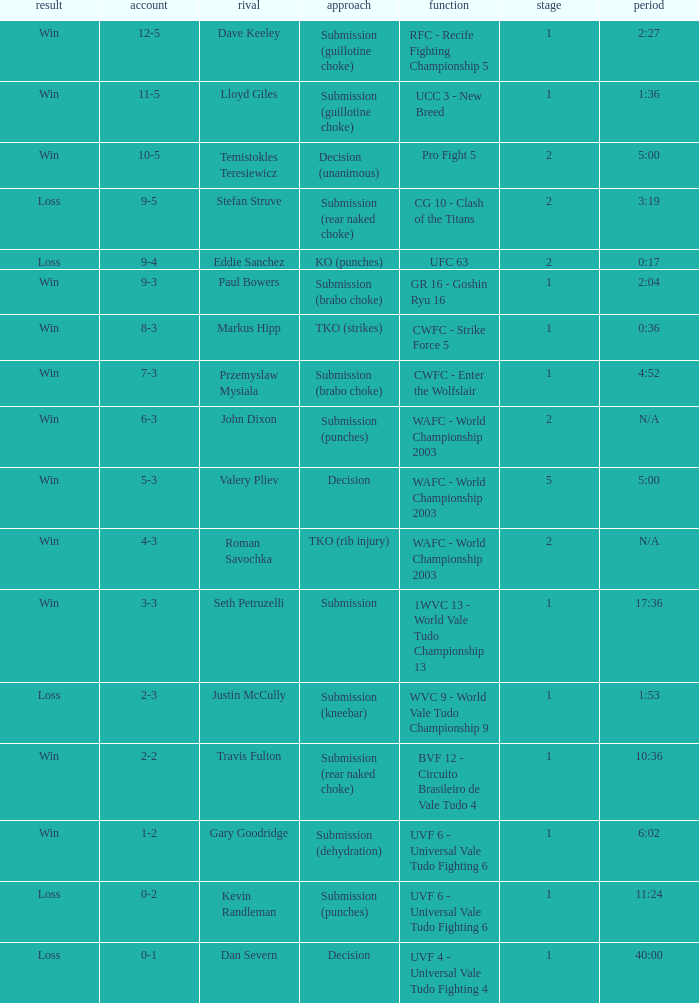What round has the highest Res loss, and a time of 40:00? 1.0. Give me the full table as a dictionary. {'header': ['result', 'account', 'rival', 'approach', 'function', 'stage', 'period'], 'rows': [['Win', '12-5', 'Dave Keeley', 'Submission (guillotine choke)', 'RFC - Recife Fighting Championship 5', '1', '2:27'], ['Win', '11-5', 'Lloyd Giles', 'Submission (guillotine choke)', 'UCC 3 - New Breed', '1', '1:36'], ['Win', '10-5', 'Temistokles Teresiewicz', 'Decision (unanimous)', 'Pro Fight 5', '2', '5:00'], ['Loss', '9-5', 'Stefan Struve', 'Submission (rear naked choke)', 'CG 10 - Clash of the Titans', '2', '3:19'], ['Loss', '9-4', 'Eddie Sanchez', 'KO (punches)', 'UFC 63', '2', '0:17'], ['Win', '9-3', 'Paul Bowers', 'Submission (brabo choke)', 'GR 16 - Goshin Ryu 16', '1', '2:04'], ['Win', '8-3', 'Markus Hipp', 'TKO (strikes)', 'CWFC - Strike Force 5', '1', '0:36'], ['Win', '7-3', 'Przemyslaw Mysiala', 'Submission (brabo choke)', 'CWFC - Enter the Wolfslair', '1', '4:52'], ['Win', '6-3', 'John Dixon', 'Submission (punches)', 'WAFC - World Championship 2003', '2', 'N/A'], ['Win', '5-3', 'Valery Pliev', 'Decision', 'WAFC - World Championship 2003', '5', '5:00'], ['Win', '4-3', 'Roman Savochka', 'TKO (rib injury)', 'WAFC - World Championship 2003', '2', 'N/A'], ['Win', '3-3', 'Seth Petruzelli', 'Submission', '1WVC 13 - World Vale Tudo Championship 13', '1', '17:36'], ['Loss', '2-3', 'Justin McCully', 'Submission (kneebar)', 'WVC 9 - World Vale Tudo Championship 9', '1', '1:53'], ['Win', '2-2', 'Travis Fulton', 'Submission (rear naked choke)', 'BVF 12 - Circuito Brasileiro de Vale Tudo 4', '1', '10:36'], ['Win', '1-2', 'Gary Goodridge', 'Submission (dehydration)', 'UVF 6 - Universal Vale Tudo Fighting 6', '1', '6:02'], ['Loss', '0-2', 'Kevin Randleman', 'Submission (punches)', 'UVF 6 - Universal Vale Tudo Fighting 6', '1', '11:24'], ['Loss', '0-1', 'Dan Severn', 'Decision', 'UVF 4 - Universal Vale Tudo Fighting 4', '1', '40:00']]} 